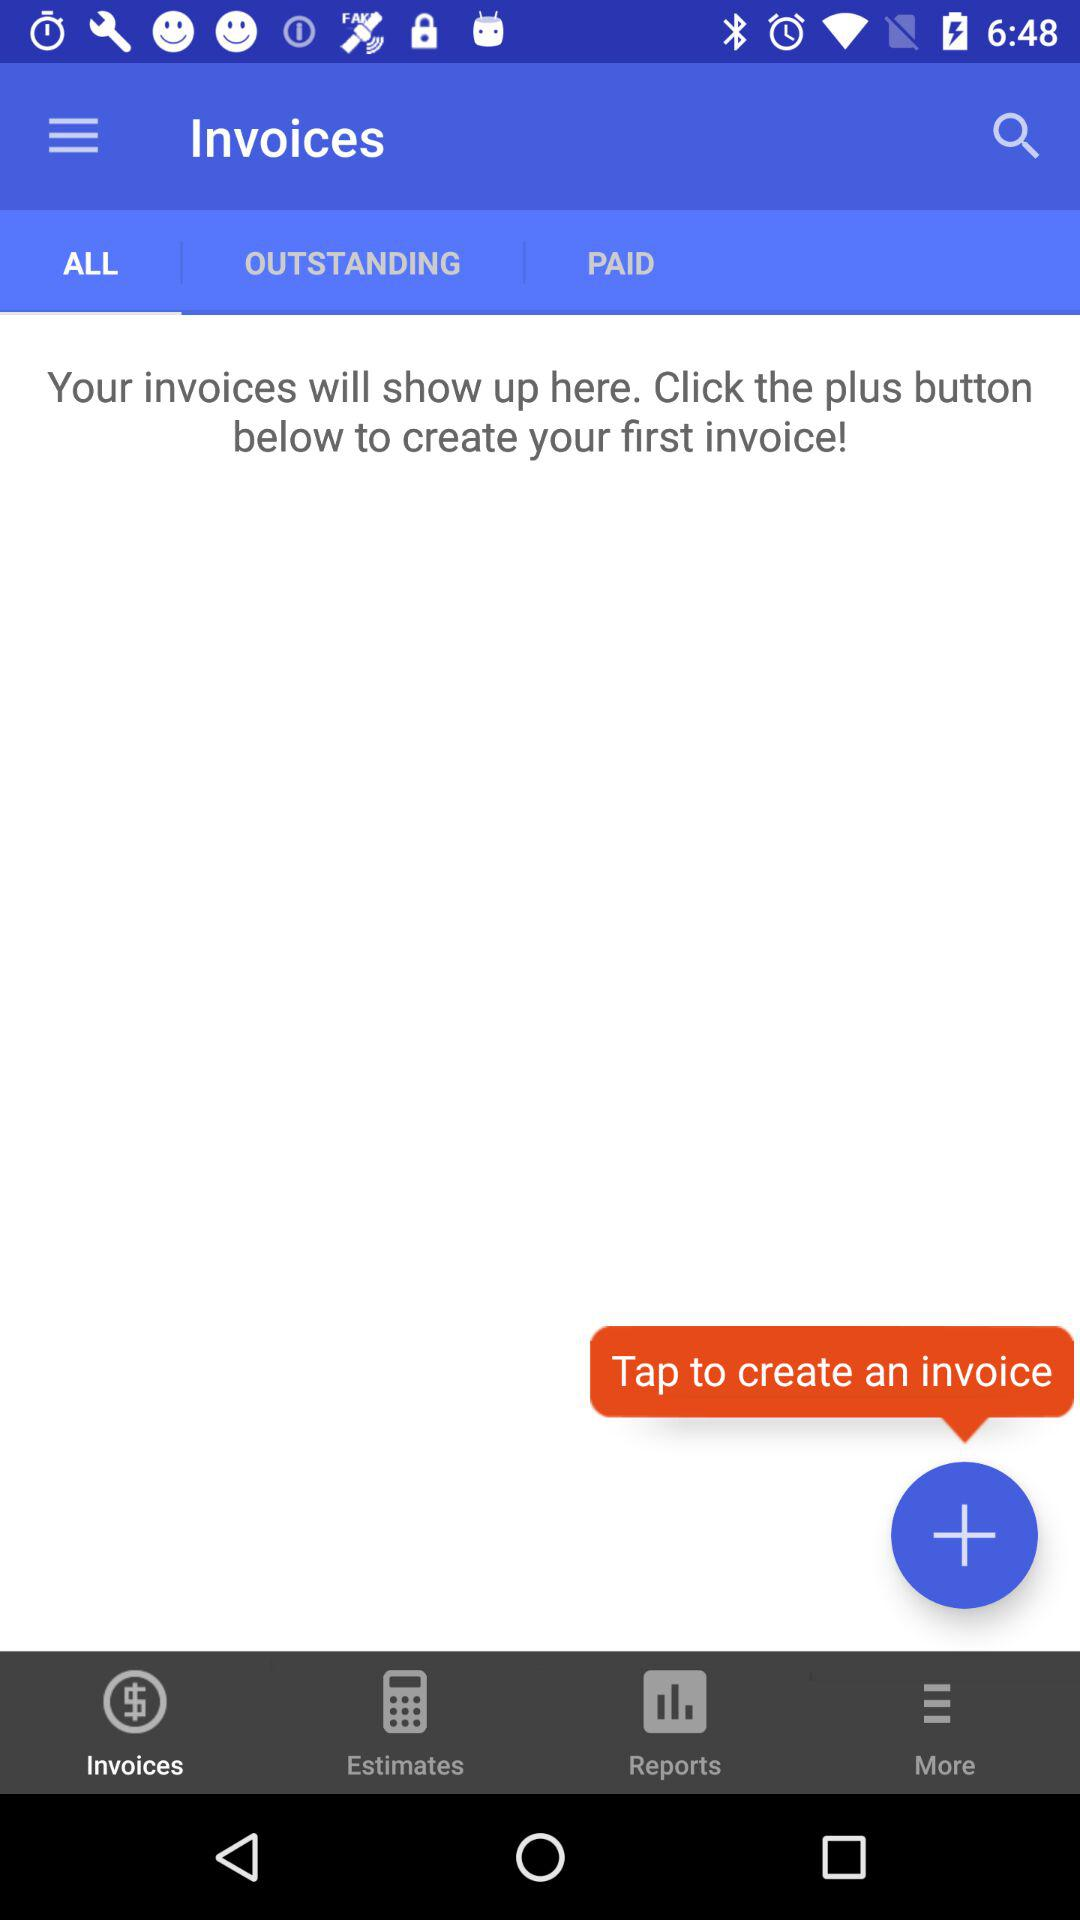What is the selected tab? The selected tab is "ALL". 